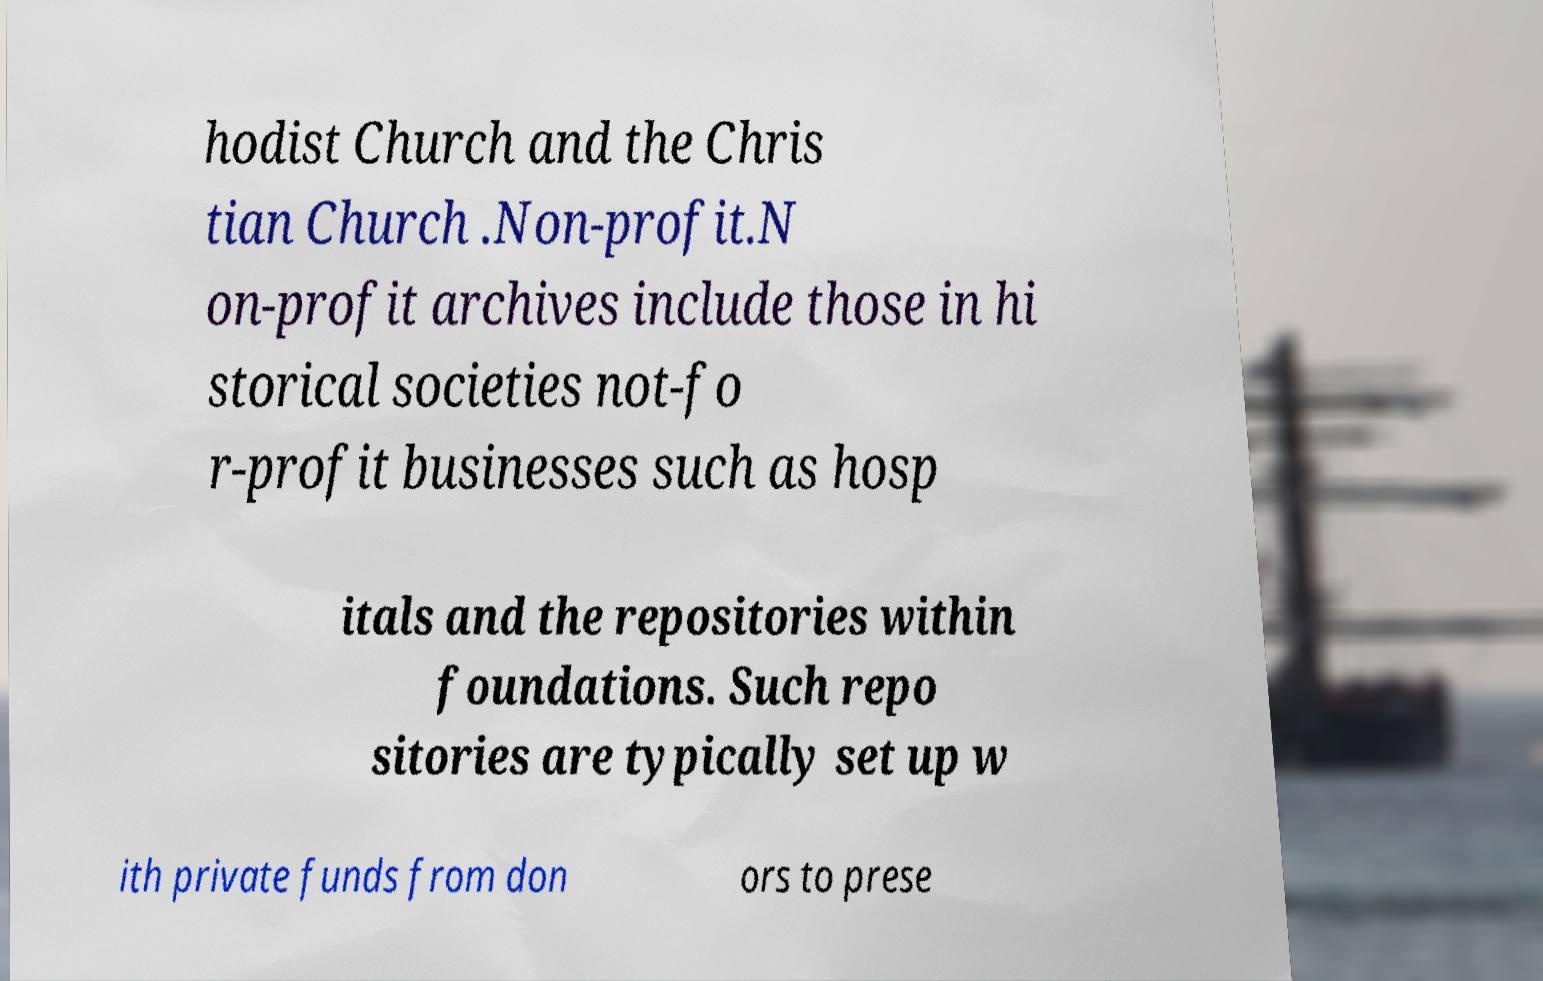Please read and relay the text visible in this image. What does it say? hodist Church and the Chris tian Church .Non-profit.N on-profit archives include those in hi storical societies not-fo r-profit businesses such as hosp itals and the repositories within foundations. Such repo sitories are typically set up w ith private funds from don ors to prese 